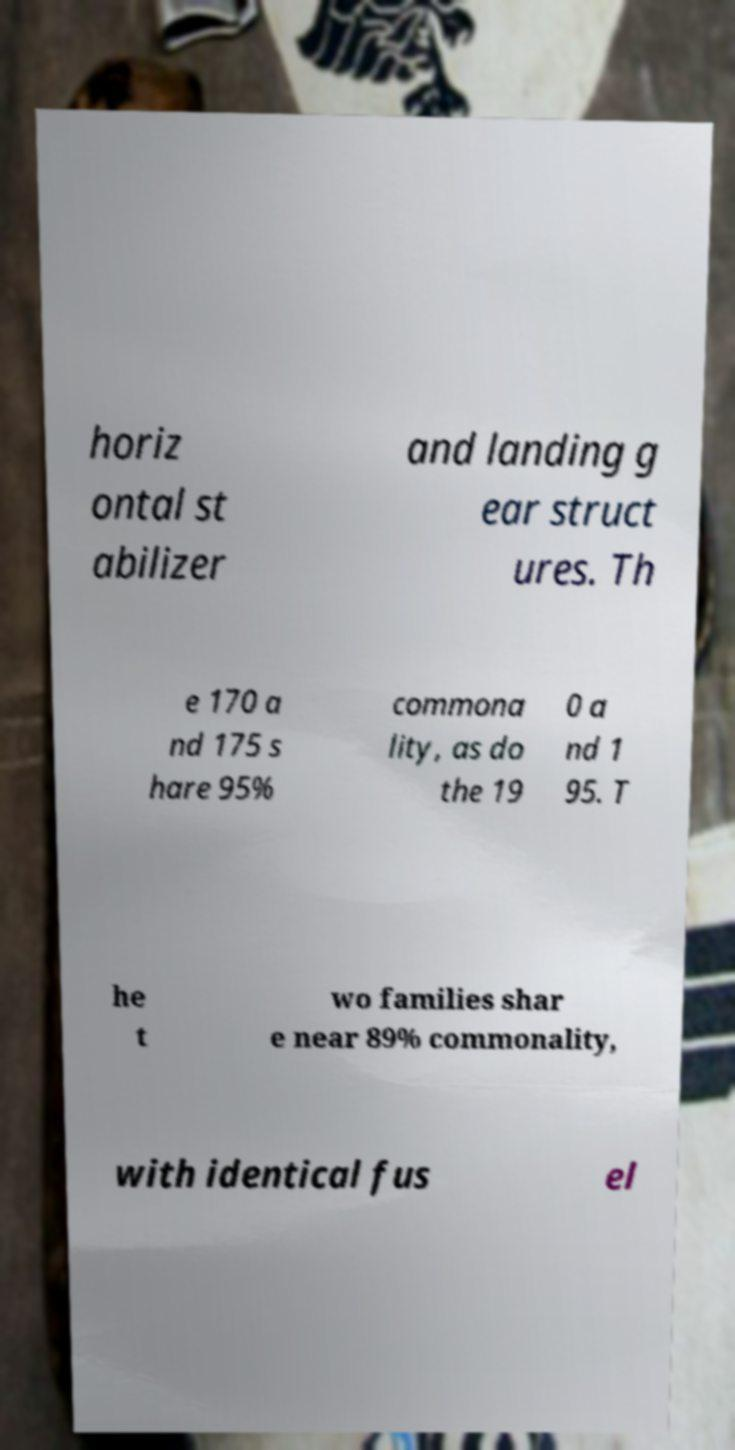Can you read and provide the text displayed in the image?This photo seems to have some interesting text. Can you extract and type it out for me? horiz ontal st abilizer and landing g ear struct ures. Th e 170 a nd 175 s hare 95% commona lity, as do the 19 0 a nd 1 95. T he t wo families shar e near 89% commonality, with identical fus el 